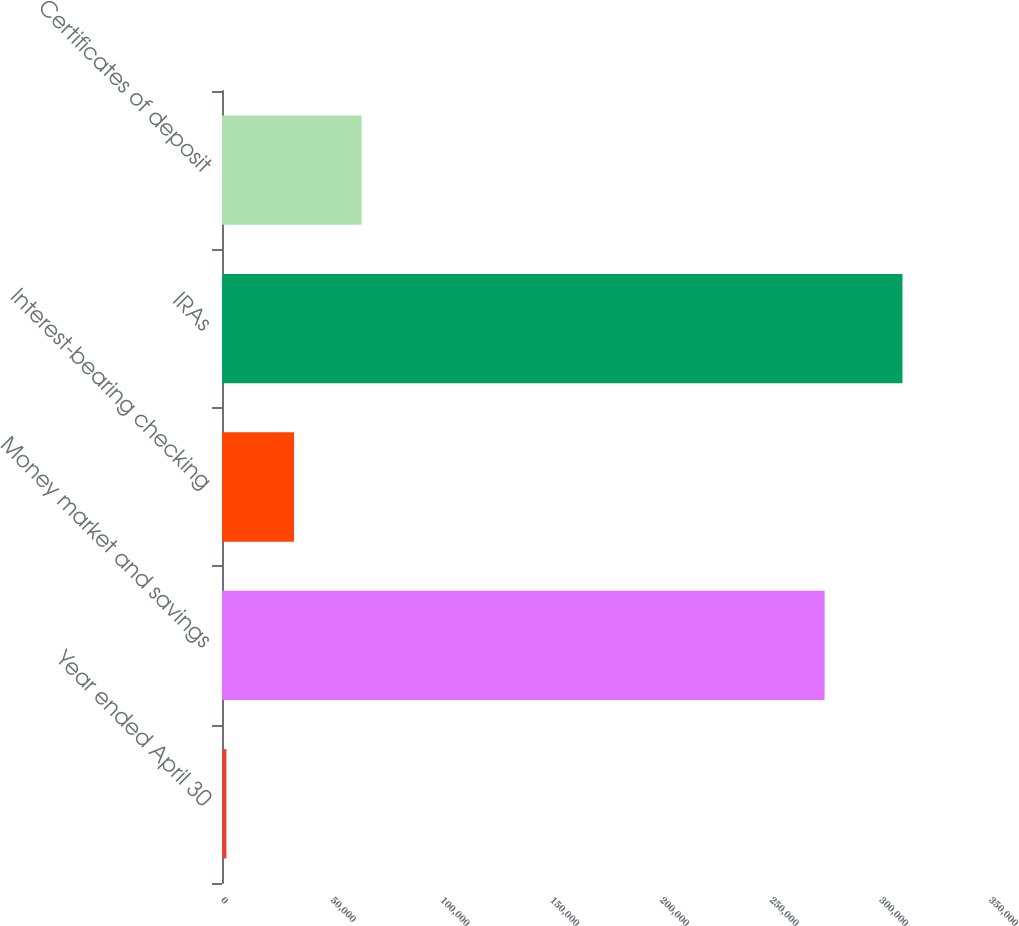<chart> <loc_0><loc_0><loc_500><loc_500><bar_chart><fcel>Year ended April 30<fcel>Money market and savings<fcel>Interest-bearing checking<fcel>IRAs<fcel>Certificates of deposit<nl><fcel>2014<fcel>274633<fcel>32822.9<fcel>310103<fcel>63631.8<nl></chart> 